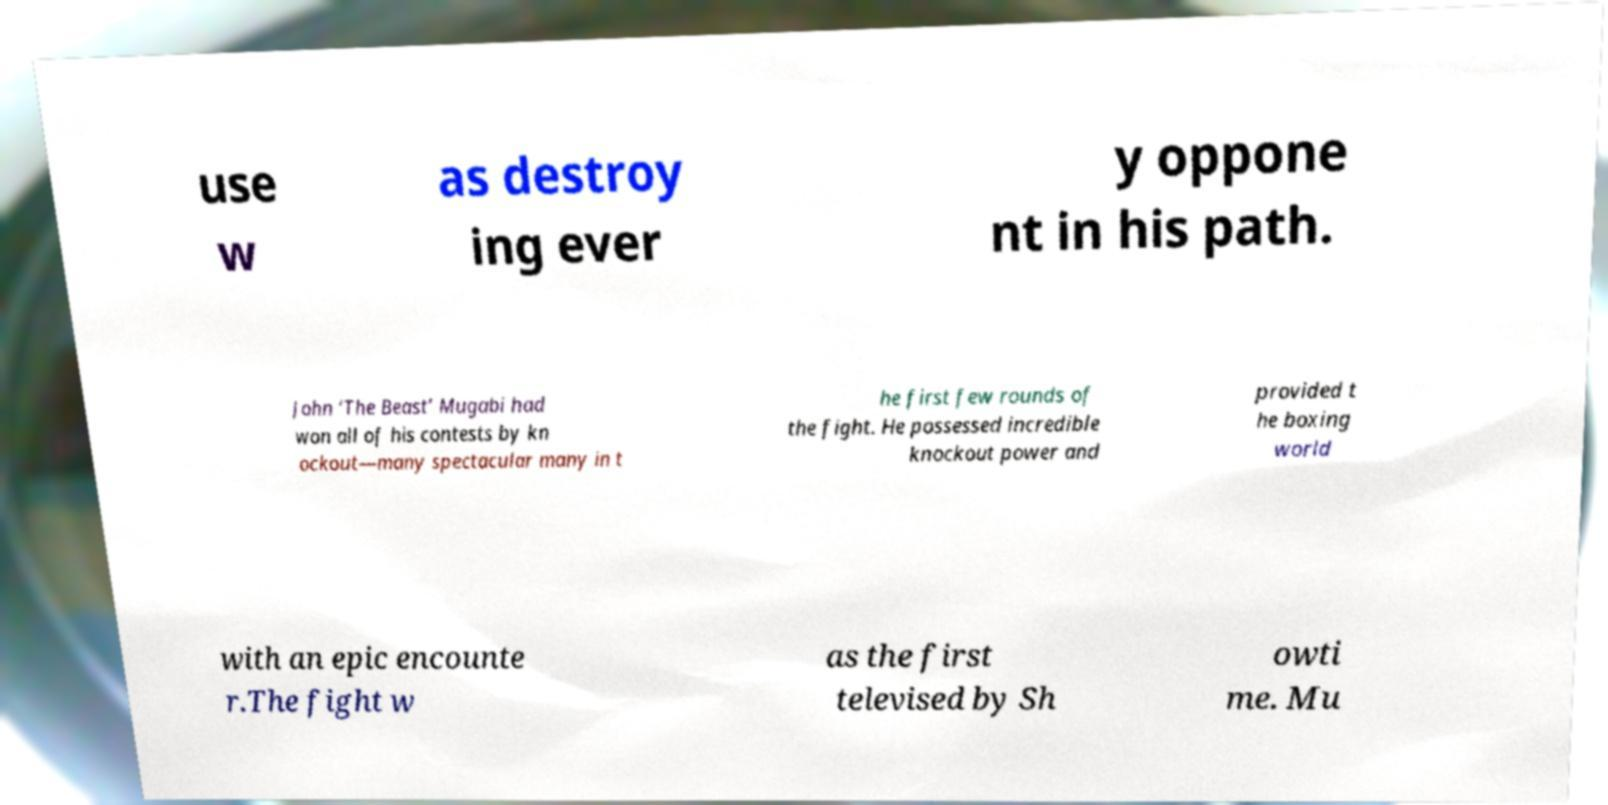I need the written content from this picture converted into text. Can you do that? use w as destroy ing ever y oppone nt in his path. John ‘The Beast’ Mugabi had won all of his contests by kn ockout—many spectacular many in t he first few rounds of the fight. He possessed incredible knockout power and provided t he boxing world with an epic encounte r.The fight w as the first televised by Sh owti me. Mu 